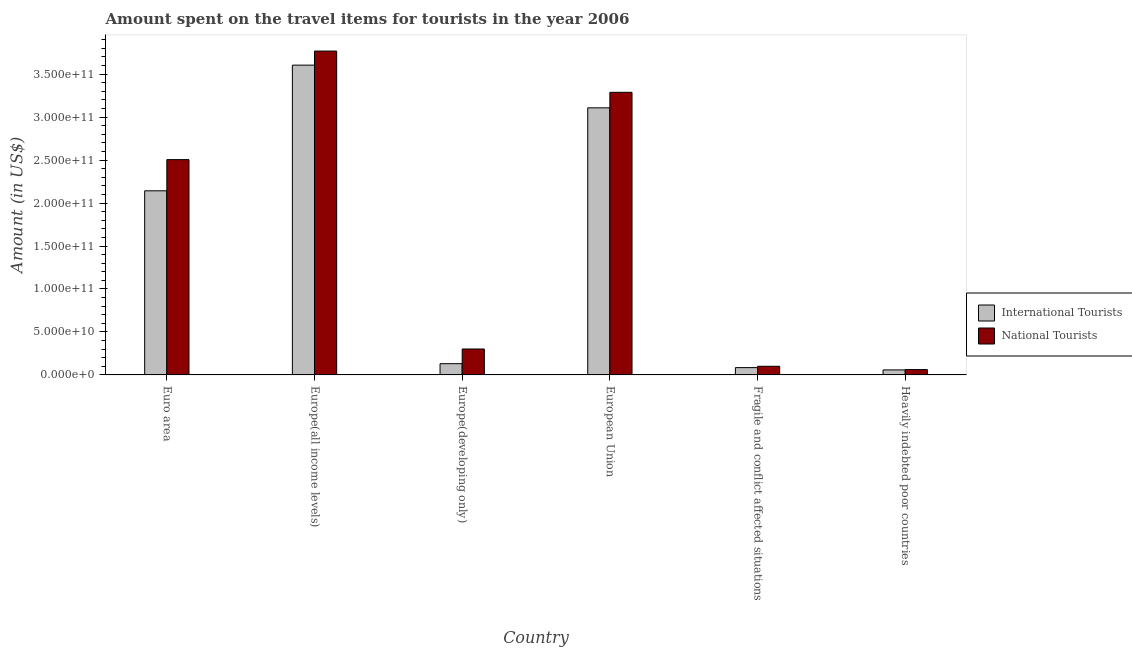Are the number of bars on each tick of the X-axis equal?
Your response must be concise. Yes. What is the label of the 5th group of bars from the left?
Offer a terse response. Fragile and conflict affected situations. In how many cases, is the number of bars for a given country not equal to the number of legend labels?
Provide a short and direct response. 0. What is the amount spent on travel items of national tourists in Europe(developing only)?
Your answer should be compact. 3.02e+1. Across all countries, what is the maximum amount spent on travel items of international tourists?
Provide a succinct answer. 3.60e+11. Across all countries, what is the minimum amount spent on travel items of national tourists?
Provide a short and direct response. 6.20e+09. In which country was the amount spent on travel items of national tourists maximum?
Make the answer very short. Europe(all income levels). In which country was the amount spent on travel items of international tourists minimum?
Provide a short and direct response. Heavily indebted poor countries. What is the total amount spent on travel items of international tourists in the graph?
Ensure brevity in your answer.  9.13e+11. What is the difference between the amount spent on travel items of international tourists in European Union and that in Heavily indebted poor countries?
Your answer should be compact. 3.05e+11. What is the difference between the amount spent on travel items of national tourists in European Union and the amount spent on travel items of international tourists in Fragile and conflict affected situations?
Give a very brief answer. 3.20e+11. What is the average amount spent on travel items of international tourists per country?
Your answer should be compact. 1.52e+11. What is the difference between the amount spent on travel items of international tourists and amount spent on travel items of national tourists in Fragile and conflict affected situations?
Keep it short and to the point. -1.56e+09. What is the ratio of the amount spent on travel items of international tourists in Euro area to that in European Union?
Provide a short and direct response. 0.69. Is the amount spent on travel items of national tourists in European Union less than that in Fragile and conflict affected situations?
Provide a short and direct response. No. What is the difference between the highest and the second highest amount spent on travel items of international tourists?
Provide a short and direct response. 4.97e+1. What is the difference between the highest and the lowest amount spent on travel items of national tourists?
Your response must be concise. 3.71e+11. In how many countries, is the amount spent on travel items of international tourists greater than the average amount spent on travel items of international tourists taken over all countries?
Ensure brevity in your answer.  3. What does the 1st bar from the left in Europe(developing only) represents?
Offer a very short reply. International Tourists. What does the 1st bar from the right in Fragile and conflict affected situations represents?
Give a very brief answer. National Tourists. How many countries are there in the graph?
Give a very brief answer. 6. How many legend labels are there?
Offer a very short reply. 2. How are the legend labels stacked?
Make the answer very short. Vertical. What is the title of the graph?
Offer a terse response. Amount spent on the travel items for tourists in the year 2006. What is the label or title of the X-axis?
Keep it short and to the point. Country. What is the label or title of the Y-axis?
Keep it short and to the point. Amount (in US$). What is the Amount (in US$) of International Tourists in Euro area?
Make the answer very short. 2.14e+11. What is the Amount (in US$) in National Tourists in Euro area?
Give a very brief answer. 2.51e+11. What is the Amount (in US$) of International Tourists in Europe(all income levels)?
Make the answer very short. 3.60e+11. What is the Amount (in US$) of National Tourists in Europe(all income levels)?
Offer a terse response. 3.77e+11. What is the Amount (in US$) of International Tourists in Europe(developing only)?
Make the answer very short. 1.30e+1. What is the Amount (in US$) in National Tourists in Europe(developing only)?
Your answer should be very brief. 3.02e+1. What is the Amount (in US$) in International Tourists in European Union?
Your answer should be very brief. 3.11e+11. What is the Amount (in US$) in National Tourists in European Union?
Your response must be concise. 3.29e+11. What is the Amount (in US$) of International Tourists in Fragile and conflict affected situations?
Offer a very short reply. 8.49e+09. What is the Amount (in US$) of National Tourists in Fragile and conflict affected situations?
Provide a succinct answer. 1.00e+1. What is the Amount (in US$) of International Tourists in Heavily indebted poor countries?
Offer a terse response. 5.82e+09. What is the Amount (in US$) of National Tourists in Heavily indebted poor countries?
Offer a terse response. 6.20e+09. Across all countries, what is the maximum Amount (in US$) in International Tourists?
Keep it short and to the point. 3.60e+11. Across all countries, what is the maximum Amount (in US$) in National Tourists?
Keep it short and to the point. 3.77e+11. Across all countries, what is the minimum Amount (in US$) of International Tourists?
Provide a short and direct response. 5.82e+09. Across all countries, what is the minimum Amount (in US$) of National Tourists?
Your answer should be very brief. 6.20e+09. What is the total Amount (in US$) of International Tourists in the graph?
Offer a very short reply. 9.13e+11. What is the total Amount (in US$) in National Tourists in the graph?
Your response must be concise. 1.00e+12. What is the difference between the Amount (in US$) of International Tourists in Euro area and that in Europe(all income levels)?
Make the answer very short. -1.46e+11. What is the difference between the Amount (in US$) of National Tourists in Euro area and that in Europe(all income levels)?
Offer a terse response. -1.26e+11. What is the difference between the Amount (in US$) in International Tourists in Euro area and that in Europe(developing only)?
Provide a succinct answer. 2.01e+11. What is the difference between the Amount (in US$) of National Tourists in Euro area and that in Europe(developing only)?
Ensure brevity in your answer.  2.20e+11. What is the difference between the Amount (in US$) in International Tourists in Euro area and that in European Union?
Offer a terse response. -9.66e+1. What is the difference between the Amount (in US$) in National Tourists in Euro area and that in European Union?
Offer a very short reply. -7.83e+1. What is the difference between the Amount (in US$) of International Tourists in Euro area and that in Fragile and conflict affected situations?
Provide a short and direct response. 2.06e+11. What is the difference between the Amount (in US$) in National Tourists in Euro area and that in Fragile and conflict affected situations?
Your answer should be compact. 2.40e+11. What is the difference between the Amount (in US$) of International Tourists in Euro area and that in Heavily indebted poor countries?
Keep it short and to the point. 2.08e+11. What is the difference between the Amount (in US$) of National Tourists in Euro area and that in Heavily indebted poor countries?
Offer a terse response. 2.44e+11. What is the difference between the Amount (in US$) of International Tourists in Europe(all income levels) and that in Europe(developing only)?
Give a very brief answer. 3.47e+11. What is the difference between the Amount (in US$) in National Tourists in Europe(all income levels) and that in Europe(developing only)?
Offer a terse response. 3.47e+11. What is the difference between the Amount (in US$) in International Tourists in Europe(all income levels) and that in European Union?
Your response must be concise. 4.97e+1. What is the difference between the Amount (in US$) in National Tourists in Europe(all income levels) and that in European Union?
Your answer should be compact. 4.80e+1. What is the difference between the Amount (in US$) of International Tourists in Europe(all income levels) and that in Fragile and conflict affected situations?
Your answer should be compact. 3.52e+11. What is the difference between the Amount (in US$) in National Tourists in Europe(all income levels) and that in Fragile and conflict affected situations?
Offer a very short reply. 3.67e+11. What is the difference between the Amount (in US$) of International Tourists in Europe(all income levels) and that in Heavily indebted poor countries?
Keep it short and to the point. 3.55e+11. What is the difference between the Amount (in US$) of National Tourists in Europe(all income levels) and that in Heavily indebted poor countries?
Keep it short and to the point. 3.71e+11. What is the difference between the Amount (in US$) of International Tourists in Europe(developing only) and that in European Union?
Provide a succinct answer. -2.98e+11. What is the difference between the Amount (in US$) of National Tourists in Europe(developing only) and that in European Union?
Your response must be concise. -2.99e+11. What is the difference between the Amount (in US$) of International Tourists in Europe(developing only) and that in Fragile and conflict affected situations?
Your response must be concise. 4.56e+09. What is the difference between the Amount (in US$) of National Tourists in Europe(developing only) and that in Fragile and conflict affected situations?
Your answer should be compact. 2.01e+1. What is the difference between the Amount (in US$) of International Tourists in Europe(developing only) and that in Heavily indebted poor countries?
Your answer should be compact. 7.23e+09. What is the difference between the Amount (in US$) of National Tourists in Europe(developing only) and that in Heavily indebted poor countries?
Keep it short and to the point. 2.40e+1. What is the difference between the Amount (in US$) of International Tourists in European Union and that in Fragile and conflict affected situations?
Provide a succinct answer. 3.02e+11. What is the difference between the Amount (in US$) in National Tourists in European Union and that in Fragile and conflict affected situations?
Make the answer very short. 3.19e+11. What is the difference between the Amount (in US$) in International Tourists in European Union and that in Heavily indebted poor countries?
Your answer should be very brief. 3.05e+11. What is the difference between the Amount (in US$) in National Tourists in European Union and that in Heavily indebted poor countries?
Make the answer very short. 3.23e+11. What is the difference between the Amount (in US$) in International Tourists in Fragile and conflict affected situations and that in Heavily indebted poor countries?
Your answer should be compact. 2.67e+09. What is the difference between the Amount (in US$) of National Tourists in Fragile and conflict affected situations and that in Heavily indebted poor countries?
Your answer should be very brief. 3.85e+09. What is the difference between the Amount (in US$) of International Tourists in Euro area and the Amount (in US$) of National Tourists in Europe(all income levels)?
Offer a very short reply. -1.63e+11. What is the difference between the Amount (in US$) in International Tourists in Euro area and the Amount (in US$) in National Tourists in Europe(developing only)?
Your response must be concise. 1.84e+11. What is the difference between the Amount (in US$) in International Tourists in Euro area and the Amount (in US$) in National Tourists in European Union?
Your answer should be compact. -1.15e+11. What is the difference between the Amount (in US$) in International Tourists in Euro area and the Amount (in US$) in National Tourists in Fragile and conflict affected situations?
Provide a succinct answer. 2.04e+11. What is the difference between the Amount (in US$) in International Tourists in Euro area and the Amount (in US$) in National Tourists in Heavily indebted poor countries?
Offer a terse response. 2.08e+11. What is the difference between the Amount (in US$) in International Tourists in Europe(all income levels) and the Amount (in US$) in National Tourists in Europe(developing only)?
Your response must be concise. 3.30e+11. What is the difference between the Amount (in US$) in International Tourists in Europe(all income levels) and the Amount (in US$) in National Tourists in European Union?
Your answer should be compact. 3.16e+1. What is the difference between the Amount (in US$) in International Tourists in Europe(all income levels) and the Amount (in US$) in National Tourists in Fragile and conflict affected situations?
Make the answer very short. 3.50e+11. What is the difference between the Amount (in US$) of International Tourists in Europe(all income levels) and the Amount (in US$) of National Tourists in Heavily indebted poor countries?
Offer a very short reply. 3.54e+11. What is the difference between the Amount (in US$) in International Tourists in Europe(developing only) and the Amount (in US$) in National Tourists in European Union?
Provide a short and direct response. -3.16e+11. What is the difference between the Amount (in US$) in International Tourists in Europe(developing only) and the Amount (in US$) in National Tourists in Fragile and conflict affected situations?
Your answer should be compact. 2.99e+09. What is the difference between the Amount (in US$) in International Tourists in Europe(developing only) and the Amount (in US$) in National Tourists in Heavily indebted poor countries?
Offer a terse response. 6.84e+09. What is the difference between the Amount (in US$) in International Tourists in European Union and the Amount (in US$) in National Tourists in Fragile and conflict affected situations?
Your answer should be very brief. 3.01e+11. What is the difference between the Amount (in US$) in International Tourists in European Union and the Amount (in US$) in National Tourists in Heavily indebted poor countries?
Provide a succinct answer. 3.05e+11. What is the difference between the Amount (in US$) in International Tourists in Fragile and conflict affected situations and the Amount (in US$) in National Tourists in Heavily indebted poor countries?
Make the answer very short. 2.28e+09. What is the average Amount (in US$) of International Tourists per country?
Your answer should be very brief. 1.52e+11. What is the average Amount (in US$) of National Tourists per country?
Give a very brief answer. 1.67e+11. What is the difference between the Amount (in US$) in International Tourists and Amount (in US$) in National Tourists in Euro area?
Give a very brief answer. -3.63e+1. What is the difference between the Amount (in US$) of International Tourists and Amount (in US$) of National Tourists in Europe(all income levels)?
Give a very brief answer. -1.64e+1. What is the difference between the Amount (in US$) in International Tourists and Amount (in US$) in National Tourists in Europe(developing only)?
Provide a short and direct response. -1.71e+1. What is the difference between the Amount (in US$) in International Tourists and Amount (in US$) in National Tourists in European Union?
Your answer should be very brief. -1.80e+1. What is the difference between the Amount (in US$) in International Tourists and Amount (in US$) in National Tourists in Fragile and conflict affected situations?
Provide a succinct answer. -1.56e+09. What is the difference between the Amount (in US$) in International Tourists and Amount (in US$) in National Tourists in Heavily indebted poor countries?
Your answer should be compact. -3.82e+08. What is the ratio of the Amount (in US$) of International Tourists in Euro area to that in Europe(all income levels)?
Provide a short and direct response. 0.59. What is the ratio of the Amount (in US$) in National Tourists in Euro area to that in Europe(all income levels)?
Keep it short and to the point. 0.66. What is the ratio of the Amount (in US$) in International Tourists in Euro area to that in Europe(developing only)?
Offer a terse response. 16.42. What is the ratio of the Amount (in US$) in National Tourists in Euro area to that in Europe(developing only)?
Your answer should be very brief. 8.31. What is the ratio of the Amount (in US$) of International Tourists in Euro area to that in European Union?
Your answer should be compact. 0.69. What is the ratio of the Amount (in US$) in National Tourists in Euro area to that in European Union?
Provide a short and direct response. 0.76. What is the ratio of the Amount (in US$) in International Tourists in Euro area to that in Fragile and conflict affected situations?
Provide a short and direct response. 25.25. What is the ratio of the Amount (in US$) in National Tourists in Euro area to that in Fragile and conflict affected situations?
Give a very brief answer. 24.93. What is the ratio of the Amount (in US$) in International Tourists in Euro area to that in Heavily indebted poor countries?
Ensure brevity in your answer.  36.82. What is the ratio of the Amount (in US$) in National Tourists in Euro area to that in Heavily indebted poor countries?
Your answer should be very brief. 40.4. What is the ratio of the Amount (in US$) in International Tourists in Europe(all income levels) to that in Europe(developing only)?
Keep it short and to the point. 27.64. What is the ratio of the Amount (in US$) of National Tourists in Europe(all income levels) to that in Europe(developing only)?
Keep it short and to the point. 12.5. What is the ratio of the Amount (in US$) of International Tourists in Europe(all income levels) to that in European Union?
Make the answer very short. 1.16. What is the ratio of the Amount (in US$) of National Tourists in Europe(all income levels) to that in European Union?
Offer a very short reply. 1.15. What is the ratio of the Amount (in US$) of International Tourists in Europe(all income levels) to that in Fragile and conflict affected situations?
Your response must be concise. 42.48. What is the ratio of the Amount (in US$) of National Tourists in Europe(all income levels) to that in Fragile and conflict affected situations?
Give a very brief answer. 37.5. What is the ratio of the Amount (in US$) in International Tourists in Europe(all income levels) to that in Heavily indebted poor countries?
Keep it short and to the point. 61.95. What is the ratio of the Amount (in US$) of National Tourists in Europe(all income levels) to that in Heavily indebted poor countries?
Provide a short and direct response. 60.77. What is the ratio of the Amount (in US$) of International Tourists in Europe(developing only) to that in European Union?
Offer a very short reply. 0.04. What is the ratio of the Amount (in US$) of National Tourists in Europe(developing only) to that in European Union?
Make the answer very short. 0.09. What is the ratio of the Amount (in US$) in International Tourists in Europe(developing only) to that in Fragile and conflict affected situations?
Keep it short and to the point. 1.54. What is the ratio of the Amount (in US$) in National Tourists in Europe(developing only) to that in Fragile and conflict affected situations?
Offer a very short reply. 3. What is the ratio of the Amount (in US$) of International Tourists in Europe(developing only) to that in Heavily indebted poor countries?
Make the answer very short. 2.24. What is the ratio of the Amount (in US$) of National Tourists in Europe(developing only) to that in Heavily indebted poor countries?
Offer a terse response. 4.86. What is the ratio of the Amount (in US$) of International Tourists in European Union to that in Fragile and conflict affected situations?
Provide a succinct answer. 36.63. What is the ratio of the Amount (in US$) of National Tourists in European Union to that in Fragile and conflict affected situations?
Make the answer very short. 32.72. What is the ratio of the Amount (in US$) in International Tourists in European Union to that in Heavily indebted poor countries?
Your answer should be compact. 53.41. What is the ratio of the Amount (in US$) of National Tourists in European Union to that in Heavily indebted poor countries?
Your response must be concise. 53.03. What is the ratio of the Amount (in US$) of International Tourists in Fragile and conflict affected situations to that in Heavily indebted poor countries?
Ensure brevity in your answer.  1.46. What is the ratio of the Amount (in US$) of National Tourists in Fragile and conflict affected situations to that in Heavily indebted poor countries?
Your answer should be very brief. 1.62. What is the difference between the highest and the second highest Amount (in US$) of International Tourists?
Keep it short and to the point. 4.97e+1. What is the difference between the highest and the second highest Amount (in US$) in National Tourists?
Provide a short and direct response. 4.80e+1. What is the difference between the highest and the lowest Amount (in US$) in International Tourists?
Your answer should be very brief. 3.55e+11. What is the difference between the highest and the lowest Amount (in US$) of National Tourists?
Make the answer very short. 3.71e+11. 